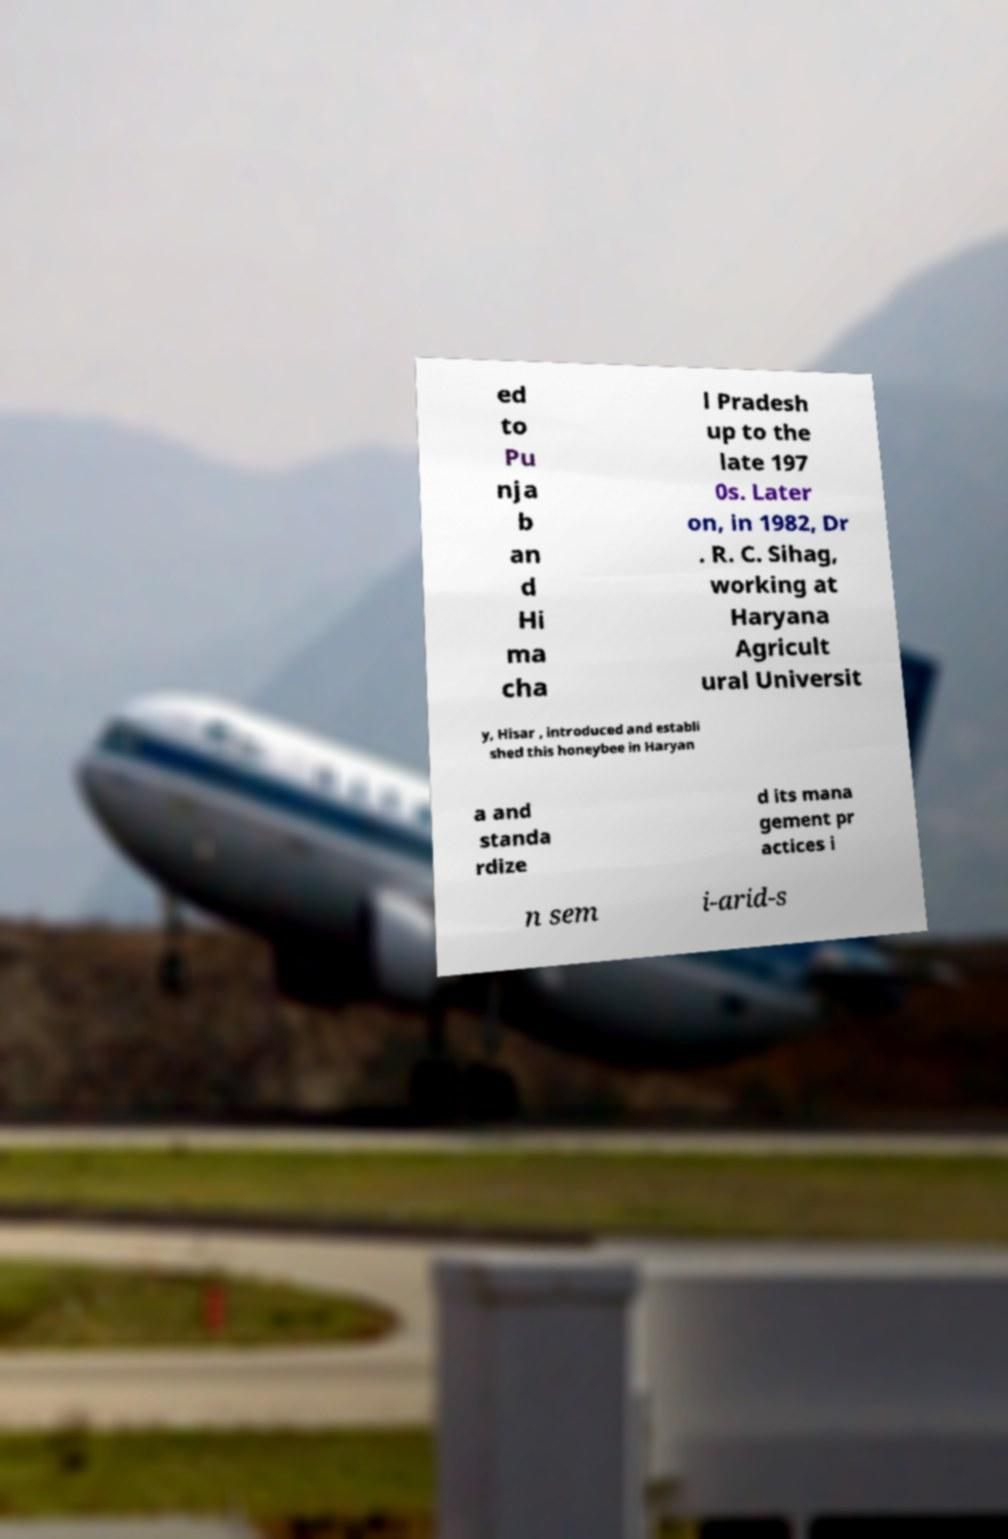I need the written content from this picture converted into text. Can you do that? ed to Pu nja b an d Hi ma cha l Pradesh up to the late 197 0s. Later on, in 1982, Dr . R. C. Sihag, working at Haryana Agricult ural Universit y, Hisar , introduced and establi shed this honeybee in Haryan a and standa rdize d its mana gement pr actices i n sem i-arid-s 